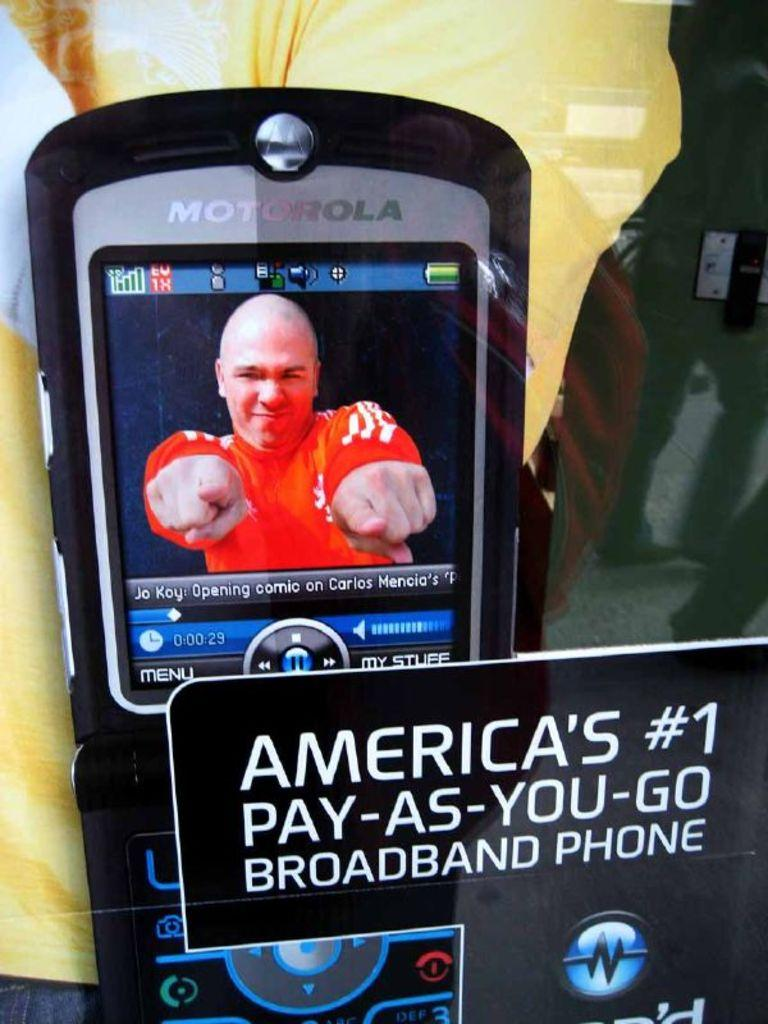What object is being used by the person in the image? There is a mobile phone in the image, and a person is using it. What might the person be doing with the mobile phone? The person could be making a call, sending a message, or using an app on the mobile phone. What additional information is provided in the image? There is text written on the image. Can you see the grandfather in the army standing next to the cactus in the image? No, there is no grandfather, army, or cactus present in the image. 